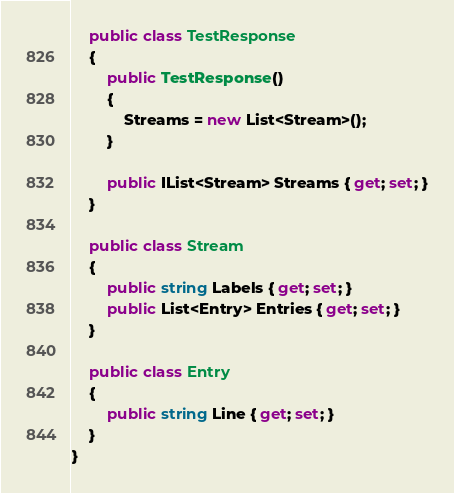Convert code to text. <code><loc_0><loc_0><loc_500><loc_500><_C#_>    public class TestResponse
    {
        public TestResponse()
        {
            Streams = new List<Stream>();
        }
        
        public IList<Stream> Streams { get; set; }
    }

    public class Stream
    {
        public string Labels { get; set; }
        public List<Entry> Entries { get; set; }
    }

    public class Entry
    {
        public string Line { get; set; }
    }
}</code> 